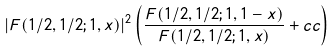Convert formula to latex. <formula><loc_0><loc_0><loc_500><loc_500>\left | F ( 1 / 2 , 1 / 2 ; 1 , x ) \right | ^ { 2 } \left ( \frac { F ( 1 / 2 , 1 / 2 ; 1 , 1 - x ) } { F ( 1 / 2 , 1 / 2 ; 1 , x ) } + c c \right )</formula> 